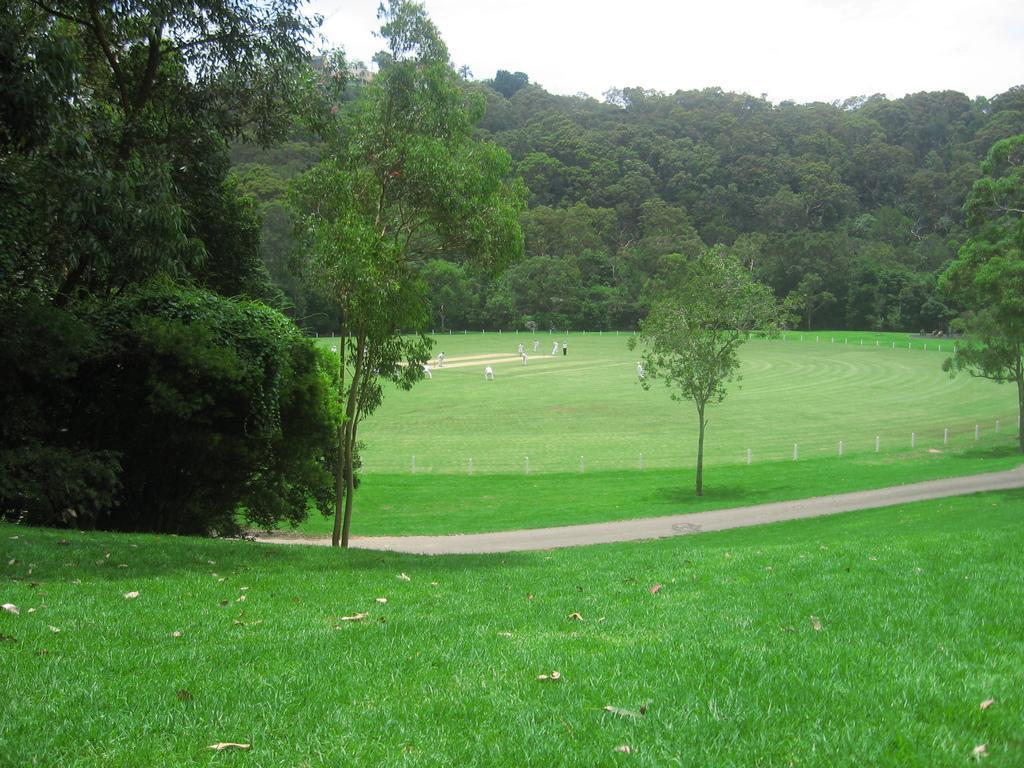Can you describe this image briefly? In this image I can see there are few people playing in the playground, there are plants and trees in the background and the sky is clear. 